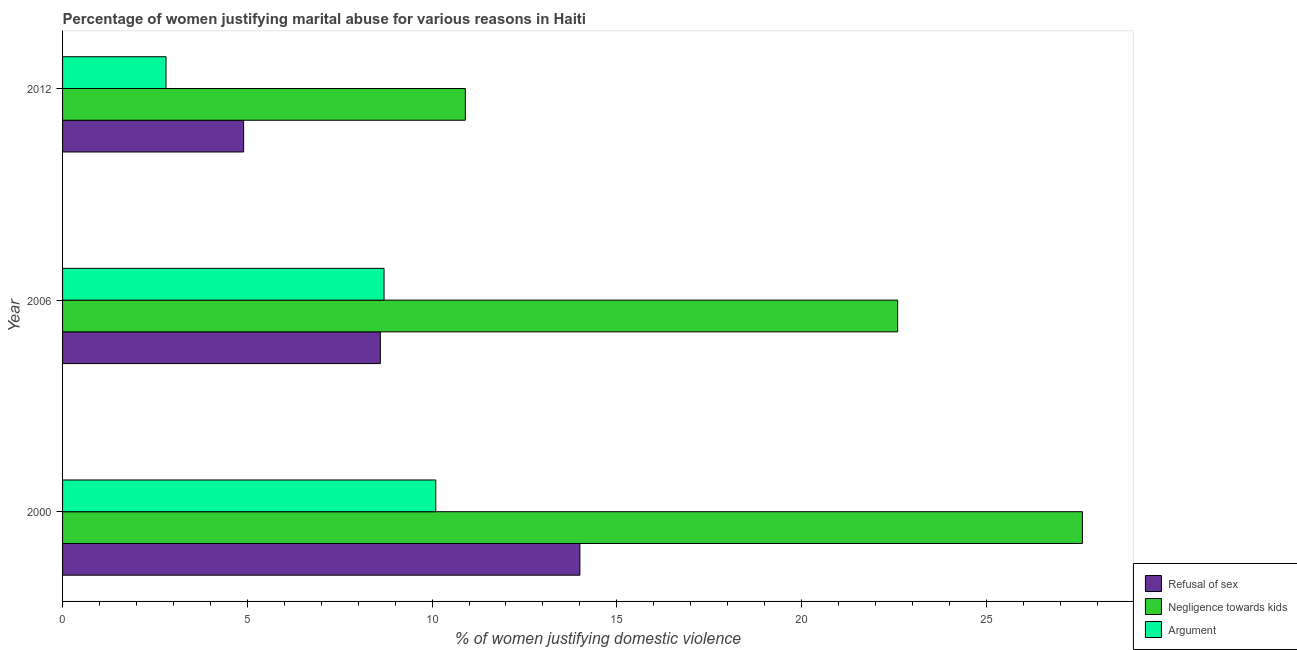How many different coloured bars are there?
Keep it short and to the point. 3. How many groups of bars are there?
Your response must be concise. 3. Are the number of bars per tick equal to the number of legend labels?
Make the answer very short. Yes. Are the number of bars on each tick of the Y-axis equal?
Provide a short and direct response. Yes. How many bars are there on the 1st tick from the top?
Keep it short and to the point. 3. What is the label of the 3rd group of bars from the top?
Provide a succinct answer. 2000. What is the percentage of women justifying domestic violence due to refusal of sex in 2000?
Make the answer very short. 14. Across all years, what is the maximum percentage of women justifying domestic violence due to refusal of sex?
Provide a short and direct response. 14. In which year was the percentage of women justifying domestic violence due to refusal of sex maximum?
Your answer should be compact. 2000. What is the total percentage of women justifying domestic violence due to arguments in the graph?
Make the answer very short. 21.6. What is the average percentage of women justifying domestic violence due to refusal of sex per year?
Make the answer very short. 9.17. In the year 2000, what is the difference between the percentage of women justifying domestic violence due to refusal of sex and percentage of women justifying domestic violence due to negligence towards kids?
Make the answer very short. -13.6. In how many years, is the percentage of women justifying domestic violence due to refusal of sex greater than 15 %?
Offer a very short reply. 0. What is the ratio of the percentage of women justifying domestic violence due to arguments in 2000 to that in 2012?
Your answer should be compact. 3.61. Is the percentage of women justifying domestic violence due to negligence towards kids in 2000 less than that in 2012?
Ensure brevity in your answer.  No. Is the difference between the percentage of women justifying domestic violence due to refusal of sex in 2006 and 2012 greater than the difference between the percentage of women justifying domestic violence due to negligence towards kids in 2006 and 2012?
Make the answer very short. No. Is the sum of the percentage of women justifying domestic violence due to refusal of sex in 2006 and 2012 greater than the maximum percentage of women justifying domestic violence due to negligence towards kids across all years?
Provide a short and direct response. No. What does the 3rd bar from the top in 2000 represents?
Offer a terse response. Refusal of sex. What does the 2nd bar from the bottom in 2006 represents?
Give a very brief answer. Negligence towards kids. Is it the case that in every year, the sum of the percentage of women justifying domestic violence due to refusal of sex and percentage of women justifying domestic violence due to negligence towards kids is greater than the percentage of women justifying domestic violence due to arguments?
Your answer should be compact. Yes. How many bars are there?
Ensure brevity in your answer.  9. How many years are there in the graph?
Your answer should be very brief. 3. What is the difference between two consecutive major ticks on the X-axis?
Your answer should be very brief. 5. Does the graph contain any zero values?
Offer a very short reply. No. Where does the legend appear in the graph?
Offer a very short reply. Bottom right. What is the title of the graph?
Provide a succinct answer. Percentage of women justifying marital abuse for various reasons in Haiti. Does "Female employers" appear as one of the legend labels in the graph?
Your answer should be very brief. No. What is the label or title of the X-axis?
Your answer should be very brief. % of women justifying domestic violence. What is the label or title of the Y-axis?
Your answer should be compact. Year. What is the % of women justifying domestic violence of Negligence towards kids in 2000?
Provide a short and direct response. 27.6. What is the % of women justifying domestic violence of Negligence towards kids in 2006?
Offer a terse response. 22.6. What is the % of women justifying domestic violence in Refusal of sex in 2012?
Keep it short and to the point. 4.9. Across all years, what is the maximum % of women justifying domestic violence of Refusal of sex?
Your response must be concise. 14. Across all years, what is the maximum % of women justifying domestic violence in Negligence towards kids?
Offer a terse response. 27.6. Across all years, what is the minimum % of women justifying domestic violence of Negligence towards kids?
Make the answer very short. 10.9. Across all years, what is the minimum % of women justifying domestic violence of Argument?
Give a very brief answer. 2.8. What is the total % of women justifying domestic violence in Negligence towards kids in the graph?
Your answer should be very brief. 61.1. What is the total % of women justifying domestic violence of Argument in the graph?
Give a very brief answer. 21.6. What is the difference between the % of women justifying domestic violence of Negligence towards kids in 2000 and that in 2006?
Give a very brief answer. 5. What is the difference between the % of women justifying domestic violence of Refusal of sex in 2000 and that in 2012?
Provide a succinct answer. 9.1. What is the difference between the % of women justifying domestic violence in Negligence towards kids in 2000 and that in 2012?
Your answer should be compact. 16.7. What is the difference between the % of women justifying domestic violence of Argument in 2006 and that in 2012?
Make the answer very short. 5.9. What is the difference between the % of women justifying domestic violence in Refusal of sex in 2000 and the % of women justifying domestic violence in Argument in 2006?
Keep it short and to the point. 5.3. What is the difference between the % of women justifying domestic violence of Negligence towards kids in 2000 and the % of women justifying domestic violence of Argument in 2006?
Your answer should be very brief. 18.9. What is the difference between the % of women justifying domestic violence of Refusal of sex in 2000 and the % of women justifying domestic violence of Argument in 2012?
Your answer should be compact. 11.2. What is the difference between the % of women justifying domestic violence in Negligence towards kids in 2000 and the % of women justifying domestic violence in Argument in 2012?
Keep it short and to the point. 24.8. What is the difference between the % of women justifying domestic violence of Negligence towards kids in 2006 and the % of women justifying domestic violence of Argument in 2012?
Your response must be concise. 19.8. What is the average % of women justifying domestic violence in Refusal of sex per year?
Make the answer very short. 9.17. What is the average % of women justifying domestic violence of Negligence towards kids per year?
Give a very brief answer. 20.37. In the year 2000, what is the difference between the % of women justifying domestic violence of Refusal of sex and % of women justifying domestic violence of Negligence towards kids?
Provide a succinct answer. -13.6. In the year 2006, what is the difference between the % of women justifying domestic violence of Refusal of sex and % of women justifying domestic violence of Negligence towards kids?
Offer a terse response. -14. What is the ratio of the % of women justifying domestic violence of Refusal of sex in 2000 to that in 2006?
Provide a short and direct response. 1.63. What is the ratio of the % of women justifying domestic violence in Negligence towards kids in 2000 to that in 2006?
Give a very brief answer. 1.22. What is the ratio of the % of women justifying domestic violence of Argument in 2000 to that in 2006?
Offer a very short reply. 1.16. What is the ratio of the % of women justifying domestic violence in Refusal of sex in 2000 to that in 2012?
Provide a succinct answer. 2.86. What is the ratio of the % of women justifying domestic violence in Negligence towards kids in 2000 to that in 2012?
Keep it short and to the point. 2.53. What is the ratio of the % of women justifying domestic violence of Argument in 2000 to that in 2012?
Provide a succinct answer. 3.61. What is the ratio of the % of women justifying domestic violence in Refusal of sex in 2006 to that in 2012?
Your response must be concise. 1.76. What is the ratio of the % of women justifying domestic violence in Negligence towards kids in 2006 to that in 2012?
Make the answer very short. 2.07. What is the ratio of the % of women justifying domestic violence of Argument in 2006 to that in 2012?
Your answer should be very brief. 3.11. What is the difference between the highest and the second highest % of women justifying domestic violence of Refusal of sex?
Your answer should be very brief. 5.4. What is the difference between the highest and the second highest % of women justifying domestic violence in Negligence towards kids?
Give a very brief answer. 5. 